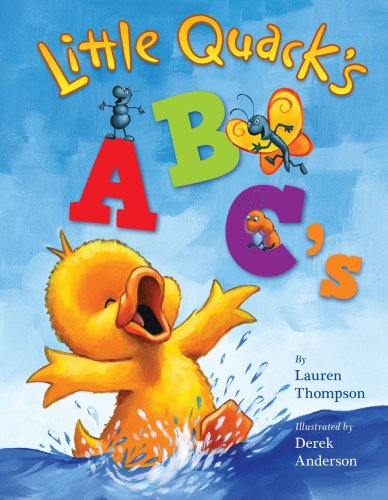Who is the author of this book? The author of 'Little Quack's ABC's' is Lauren Thompson, a well-known writer of many beloved children's books. 